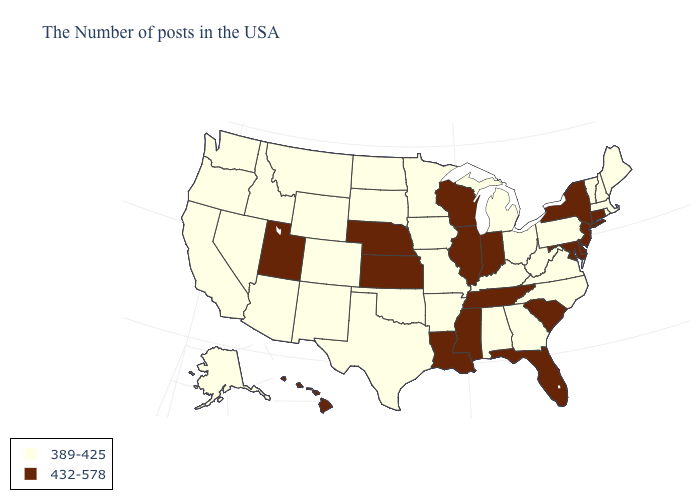Does Hawaii have the highest value in the USA?
Concise answer only. Yes. What is the value of Maryland?
Answer briefly. 432-578. Name the states that have a value in the range 432-578?
Give a very brief answer. Connecticut, New York, New Jersey, Delaware, Maryland, South Carolina, Florida, Indiana, Tennessee, Wisconsin, Illinois, Mississippi, Louisiana, Kansas, Nebraska, Utah, Hawaii. What is the highest value in the West ?
Short answer required. 432-578. What is the highest value in the West ?
Give a very brief answer. 432-578. Name the states that have a value in the range 432-578?
Concise answer only. Connecticut, New York, New Jersey, Delaware, Maryland, South Carolina, Florida, Indiana, Tennessee, Wisconsin, Illinois, Mississippi, Louisiana, Kansas, Nebraska, Utah, Hawaii. Name the states that have a value in the range 432-578?
Write a very short answer. Connecticut, New York, New Jersey, Delaware, Maryland, South Carolina, Florida, Indiana, Tennessee, Wisconsin, Illinois, Mississippi, Louisiana, Kansas, Nebraska, Utah, Hawaii. Name the states that have a value in the range 389-425?
Concise answer only. Maine, Massachusetts, Rhode Island, New Hampshire, Vermont, Pennsylvania, Virginia, North Carolina, West Virginia, Ohio, Georgia, Michigan, Kentucky, Alabama, Missouri, Arkansas, Minnesota, Iowa, Oklahoma, Texas, South Dakota, North Dakota, Wyoming, Colorado, New Mexico, Montana, Arizona, Idaho, Nevada, California, Washington, Oregon, Alaska. What is the value of Hawaii?
Concise answer only. 432-578. Does the first symbol in the legend represent the smallest category?
Concise answer only. Yes. Does the map have missing data?
Keep it brief. No. Among the states that border Tennessee , does Missouri have the highest value?
Keep it brief. No. Does Indiana have a lower value than Utah?
Quick response, please. No. Name the states that have a value in the range 432-578?
Concise answer only. Connecticut, New York, New Jersey, Delaware, Maryland, South Carolina, Florida, Indiana, Tennessee, Wisconsin, Illinois, Mississippi, Louisiana, Kansas, Nebraska, Utah, Hawaii. Which states have the lowest value in the USA?
Quick response, please. Maine, Massachusetts, Rhode Island, New Hampshire, Vermont, Pennsylvania, Virginia, North Carolina, West Virginia, Ohio, Georgia, Michigan, Kentucky, Alabama, Missouri, Arkansas, Minnesota, Iowa, Oklahoma, Texas, South Dakota, North Dakota, Wyoming, Colorado, New Mexico, Montana, Arizona, Idaho, Nevada, California, Washington, Oregon, Alaska. 